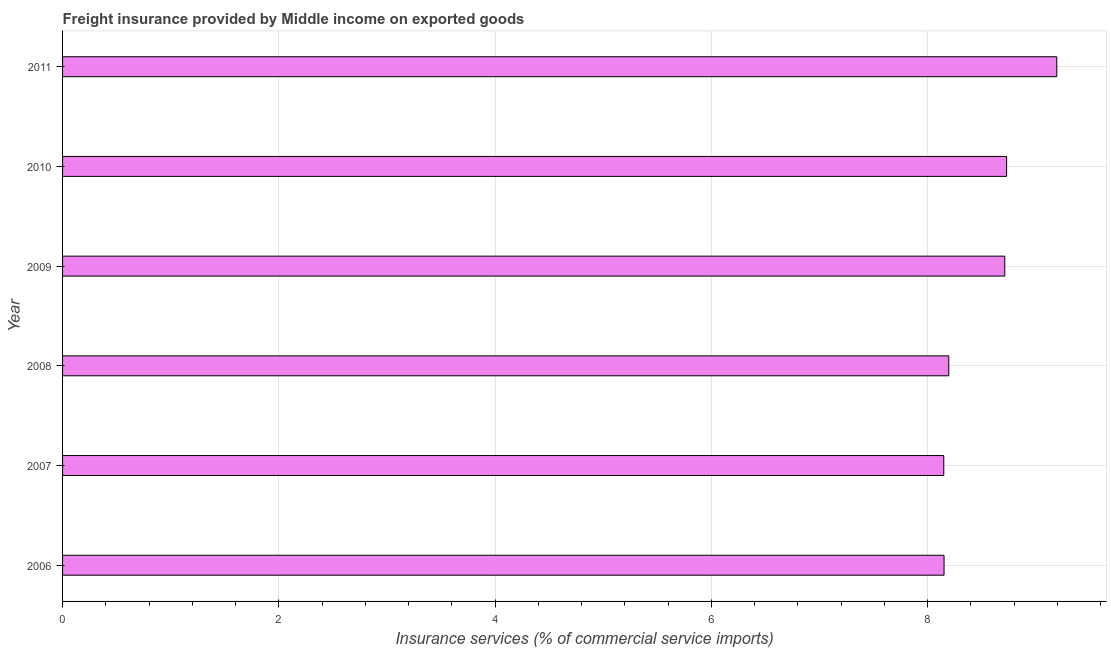What is the title of the graph?
Keep it short and to the point. Freight insurance provided by Middle income on exported goods . What is the label or title of the X-axis?
Provide a succinct answer. Insurance services (% of commercial service imports). What is the label or title of the Y-axis?
Your answer should be very brief. Year. What is the freight insurance in 2006?
Provide a succinct answer. 8.15. Across all years, what is the maximum freight insurance?
Your answer should be compact. 9.2. Across all years, what is the minimum freight insurance?
Your response must be concise. 8.15. In which year was the freight insurance maximum?
Your answer should be very brief. 2011. What is the sum of the freight insurance?
Your answer should be compact. 51.14. What is the difference between the freight insurance in 2008 and 2010?
Ensure brevity in your answer.  -0.54. What is the average freight insurance per year?
Make the answer very short. 8.52. What is the median freight insurance?
Provide a short and direct response. 8.46. What is the ratio of the freight insurance in 2007 to that in 2010?
Give a very brief answer. 0.93. Is the freight insurance in 2008 less than that in 2010?
Your answer should be very brief. Yes. What is the difference between the highest and the second highest freight insurance?
Offer a terse response. 0.46. What is the difference between the highest and the lowest freight insurance?
Provide a short and direct response. 1.05. In how many years, is the freight insurance greater than the average freight insurance taken over all years?
Give a very brief answer. 3. What is the difference between two consecutive major ticks on the X-axis?
Give a very brief answer. 2. Are the values on the major ticks of X-axis written in scientific E-notation?
Provide a short and direct response. No. What is the Insurance services (% of commercial service imports) of 2006?
Provide a succinct answer. 8.15. What is the Insurance services (% of commercial service imports) in 2007?
Your response must be concise. 8.15. What is the Insurance services (% of commercial service imports) in 2008?
Offer a terse response. 8.2. What is the Insurance services (% of commercial service imports) in 2009?
Make the answer very short. 8.71. What is the Insurance services (% of commercial service imports) of 2010?
Make the answer very short. 8.73. What is the Insurance services (% of commercial service imports) of 2011?
Give a very brief answer. 9.2. What is the difference between the Insurance services (% of commercial service imports) in 2006 and 2007?
Keep it short and to the point. 0. What is the difference between the Insurance services (% of commercial service imports) in 2006 and 2008?
Ensure brevity in your answer.  -0.04. What is the difference between the Insurance services (% of commercial service imports) in 2006 and 2009?
Ensure brevity in your answer.  -0.56. What is the difference between the Insurance services (% of commercial service imports) in 2006 and 2010?
Give a very brief answer. -0.58. What is the difference between the Insurance services (% of commercial service imports) in 2006 and 2011?
Your answer should be very brief. -1.04. What is the difference between the Insurance services (% of commercial service imports) in 2007 and 2008?
Your answer should be compact. -0.05. What is the difference between the Insurance services (% of commercial service imports) in 2007 and 2009?
Your response must be concise. -0.56. What is the difference between the Insurance services (% of commercial service imports) in 2007 and 2010?
Give a very brief answer. -0.58. What is the difference between the Insurance services (% of commercial service imports) in 2007 and 2011?
Keep it short and to the point. -1.05. What is the difference between the Insurance services (% of commercial service imports) in 2008 and 2009?
Your answer should be very brief. -0.52. What is the difference between the Insurance services (% of commercial service imports) in 2008 and 2010?
Offer a terse response. -0.54. What is the difference between the Insurance services (% of commercial service imports) in 2008 and 2011?
Make the answer very short. -1. What is the difference between the Insurance services (% of commercial service imports) in 2009 and 2010?
Give a very brief answer. -0.02. What is the difference between the Insurance services (% of commercial service imports) in 2009 and 2011?
Keep it short and to the point. -0.48. What is the difference between the Insurance services (% of commercial service imports) in 2010 and 2011?
Offer a very short reply. -0.46. What is the ratio of the Insurance services (% of commercial service imports) in 2006 to that in 2009?
Offer a very short reply. 0.94. What is the ratio of the Insurance services (% of commercial service imports) in 2006 to that in 2010?
Ensure brevity in your answer.  0.93. What is the ratio of the Insurance services (% of commercial service imports) in 2006 to that in 2011?
Give a very brief answer. 0.89. What is the ratio of the Insurance services (% of commercial service imports) in 2007 to that in 2009?
Offer a terse response. 0.94. What is the ratio of the Insurance services (% of commercial service imports) in 2007 to that in 2010?
Offer a terse response. 0.93. What is the ratio of the Insurance services (% of commercial service imports) in 2007 to that in 2011?
Give a very brief answer. 0.89. What is the ratio of the Insurance services (% of commercial service imports) in 2008 to that in 2009?
Your response must be concise. 0.94. What is the ratio of the Insurance services (% of commercial service imports) in 2008 to that in 2010?
Ensure brevity in your answer.  0.94. What is the ratio of the Insurance services (% of commercial service imports) in 2008 to that in 2011?
Make the answer very short. 0.89. What is the ratio of the Insurance services (% of commercial service imports) in 2009 to that in 2011?
Keep it short and to the point. 0.95. 